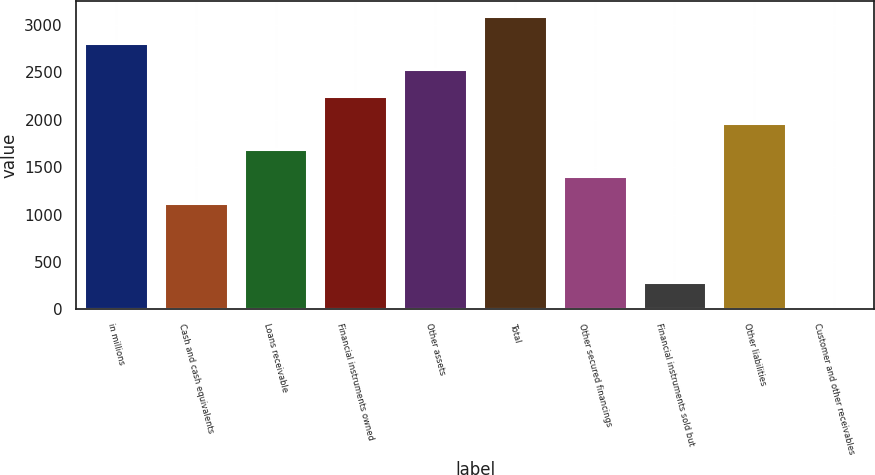<chart> <loc_0><loc_0><loc_500><loc_500><bar_chart><fcel>in millions<fcel>Cash and cash equivalents<fcel>Loans receivable<fcel>Financial instruments owned<fcel>Other assets<fcel>Total<fcel>Other secured financings<fcel>Financial instruments sold but<fcel>Other liabilities<fcel>Customer and other receivables<nl><fcel>2813<fcel>1126.4<fcel>1688.6<fcel>2250.8<fcel>2531.9<fcel>3094.1<fcel>1407.5<fcel>283.1<fcel>1969.7<fcel>2<nl></chart> 